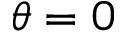Convert formula to latex. <formula><loc_0><loc_0><loc_500><loc_500>\theta = 0</formula> 